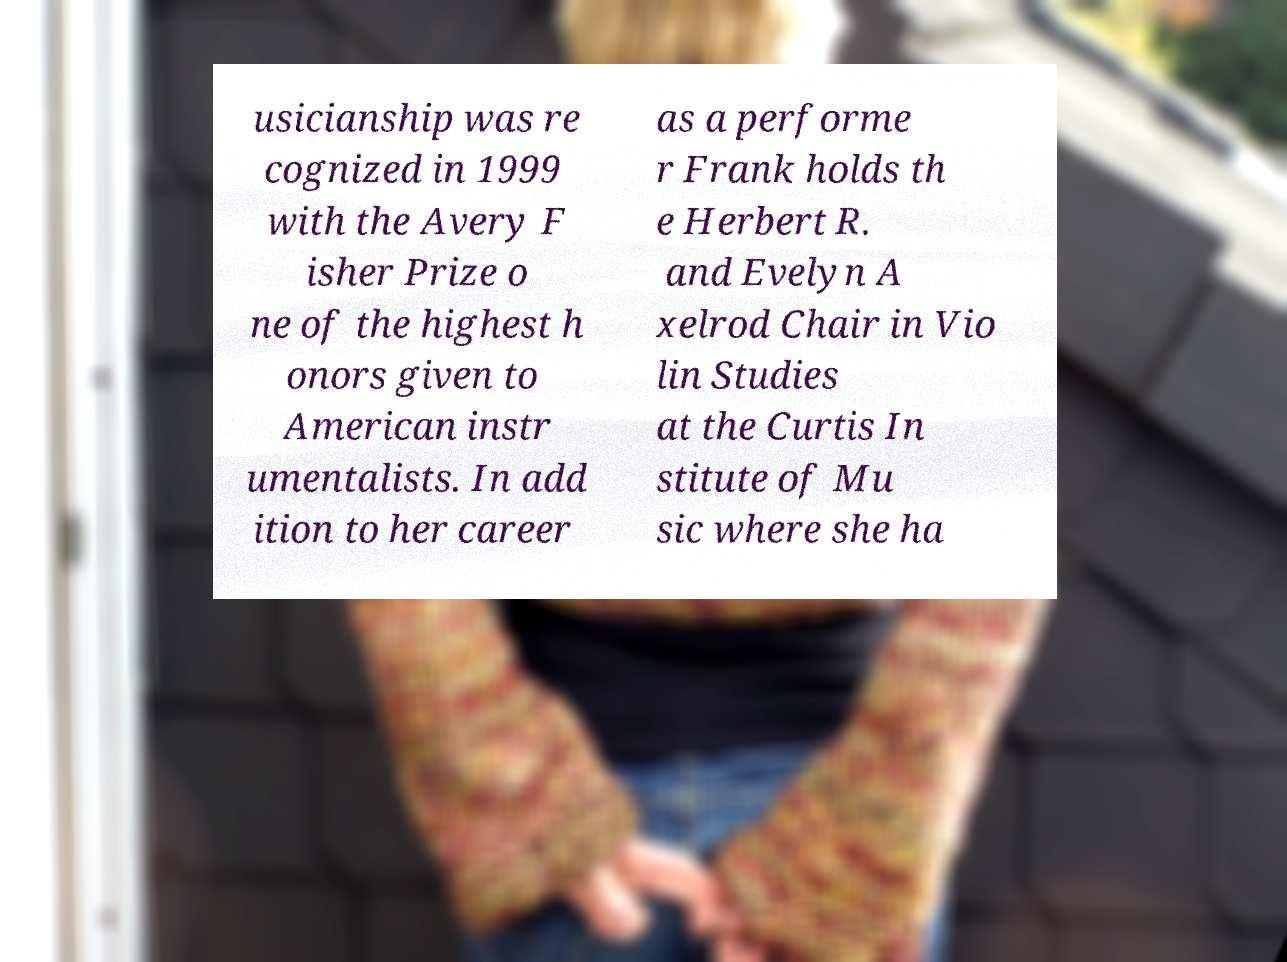For documentation purposes, I need the text within this image transcribed. Could you provide that? usicianship was re cognized in 1999 with the Avery F isher Prize o ne of the highest h onors given to American instr umentalists. In add ition to her career as a performe r Frank holds th e Herbert R. and Evelyn A xelrod Chair in Vio lin Studies at the Curtis In stitute of Mu sic where she ha 